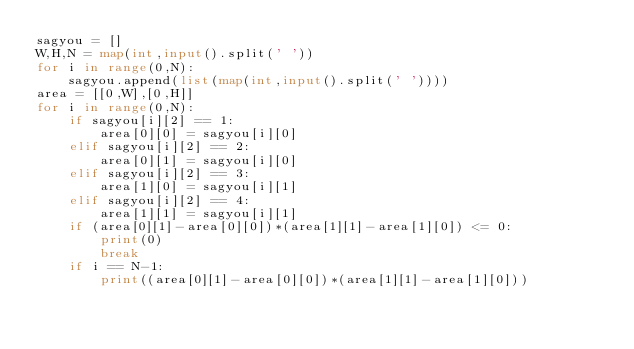<code> <loc_0><loc_0><loc_500><loc_500><_Python_>sagyou = []
W,H,N = map(int,input().split(' '))
for i in range(0,N):
    sagyou.append(list(map(int,input().split(' '))))
area = [[0,W],[0,H]]
for i in range(0,N):
    if sagyou[i][2] == 1:
        area[0][0] = sagyou[i][0]
    elif sagyou[i][2] == 2:
        area[0][1] = sagyou[i][0]
    elif sagyou[i][2] == 3:
        area[1][0] = sagyou[i][1]
    elif sagyou[i][2] == 4:
        area[1][1] = sagyou[i][1]
    if (area[0][1]-area[0][0])*(area[1][1]-area[1][0]) <= 0:
        print(0)
        break
    if i == N-1:
        print((area[0][1]-area[0][0])*(area[1][1]-area[1][0]))</code> 